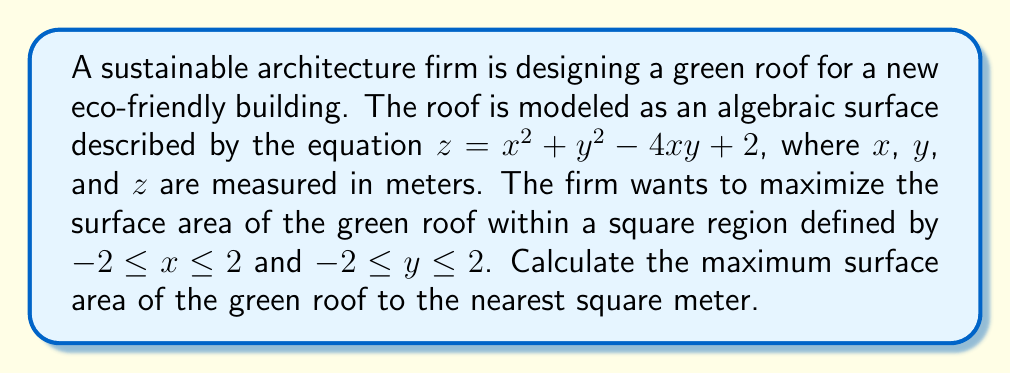Give your solution to this math problem. To find the surface area of the green roof, we need to use the surface area formula for a parametric surface:

$$A = \iint_R \sqrt{1 + \left(\frac{\partial z}{\partial x}\right)^2 + \left(\frac{\partial z}{\partial y}\right)^2} \,dxdy$$

where $R$ is the region of integration.

Step 1: Calculate the partial derivatives
$$\frac{\partial z}{\partial x} = 2x - 4y$$
$$\frac{\partial z}{\partial y} = 2y - 4x$$

Step 2: Substitute into the surface area formula
$$A = \int_{-2}^2 \int_{-2}^2 \sqrt{1 + (2x - 4y)^2 + (2y - 4x)^2} \,dxdy$$

Step 3: Simplify the integrand
$$\sqrt{1 + (2x - 4y)^2 + (2y - 4x)^2} = \sqrt{1 + 4x^2 - 16xy + 16y^2 + 4y^2 - 16xy + 16x^2}$$
$$= \sqrt{1 + 20x^2 + 20y^2 - 32xy}$$
$$= \sqrt{1 + 20(x^2 + y^2 - \frac{8}{5}xy)}$$

Step 4: The integral cannot be solved analytically, so we need to use numerical integration. We can use a computer algebra system or numerical integration technique like Simpson's rule or the trapezoidal rule to evaluate the double integral.

Step 5: Using numerical integration, we find that the surface area is approximately 34.54 square meters.
Answer: 35 square meters 